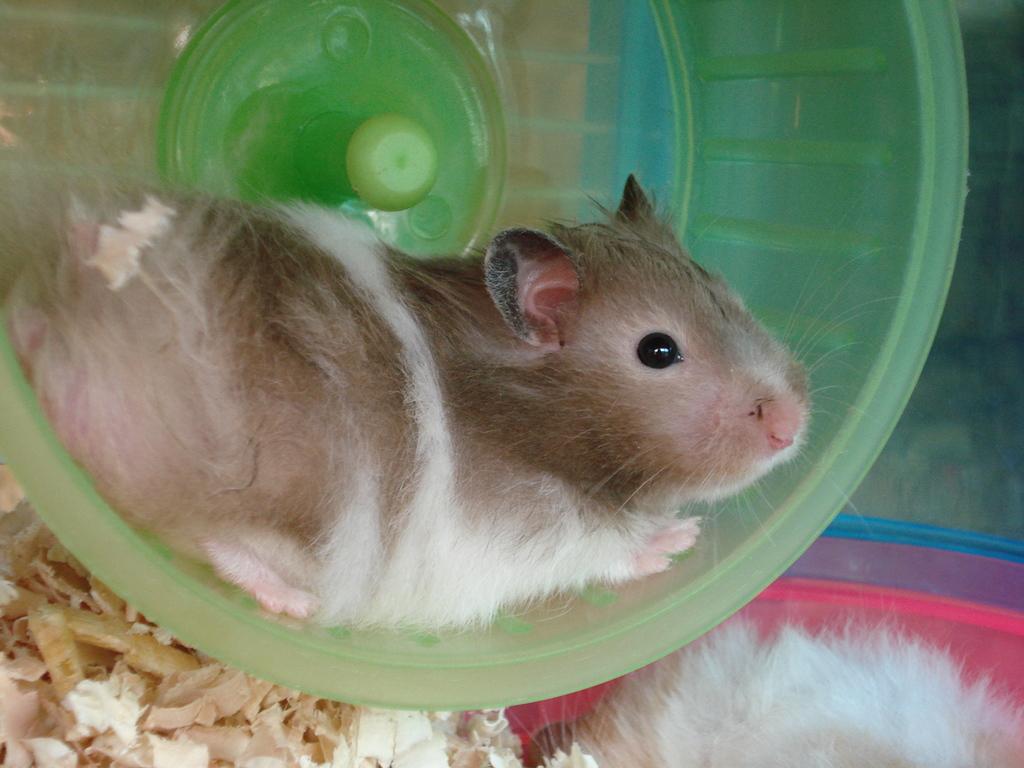Can you describe this image briefly? In the picture I can see a rat is in the green color object. At the bottom of the image we can see some objects and another rat, we can see some objects which are in red and black color. 